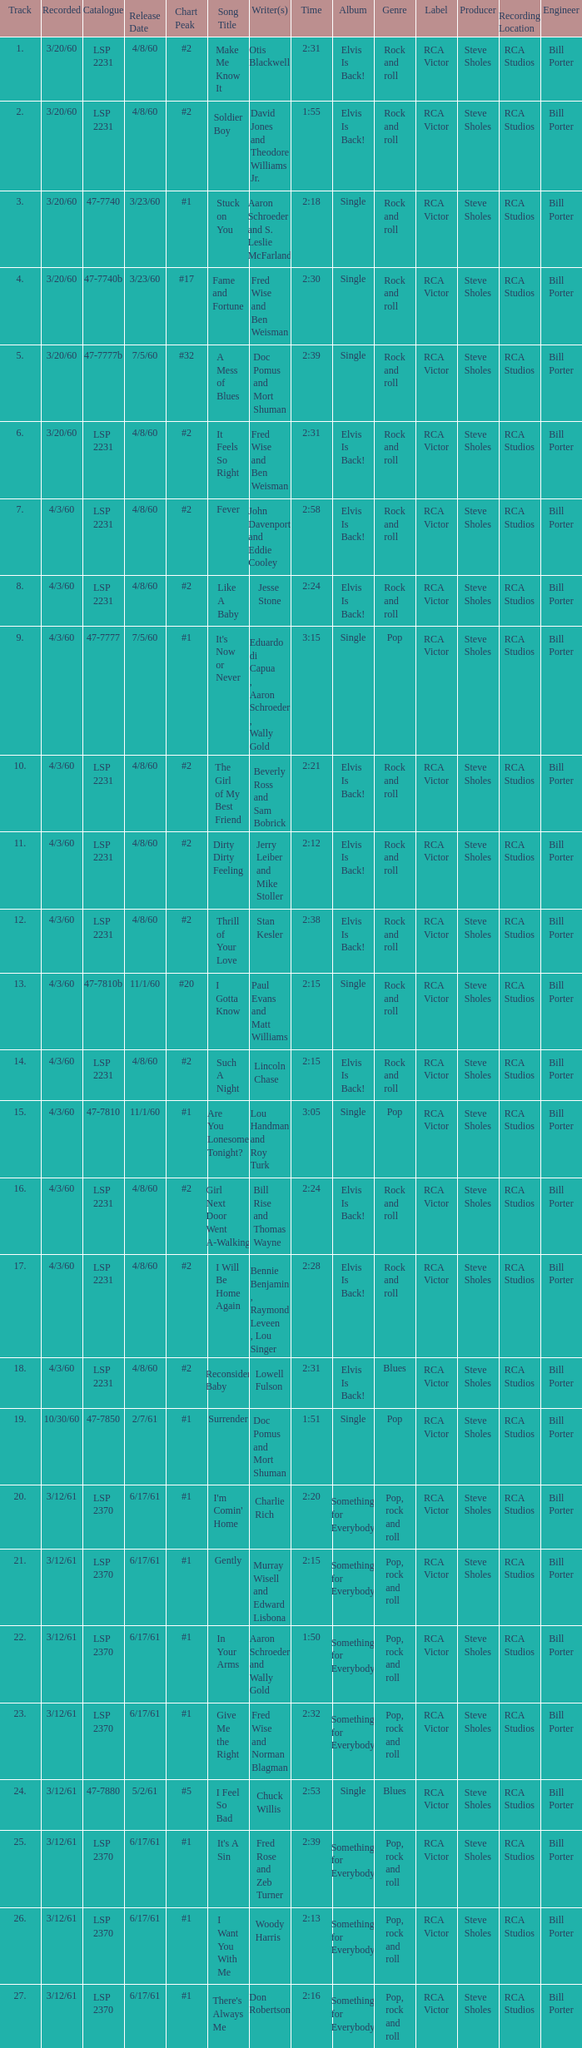On songs that have a release date of 6/17/61, a track larger than 20, and a writer of Woody Harris, what is the chart peak? #1. 